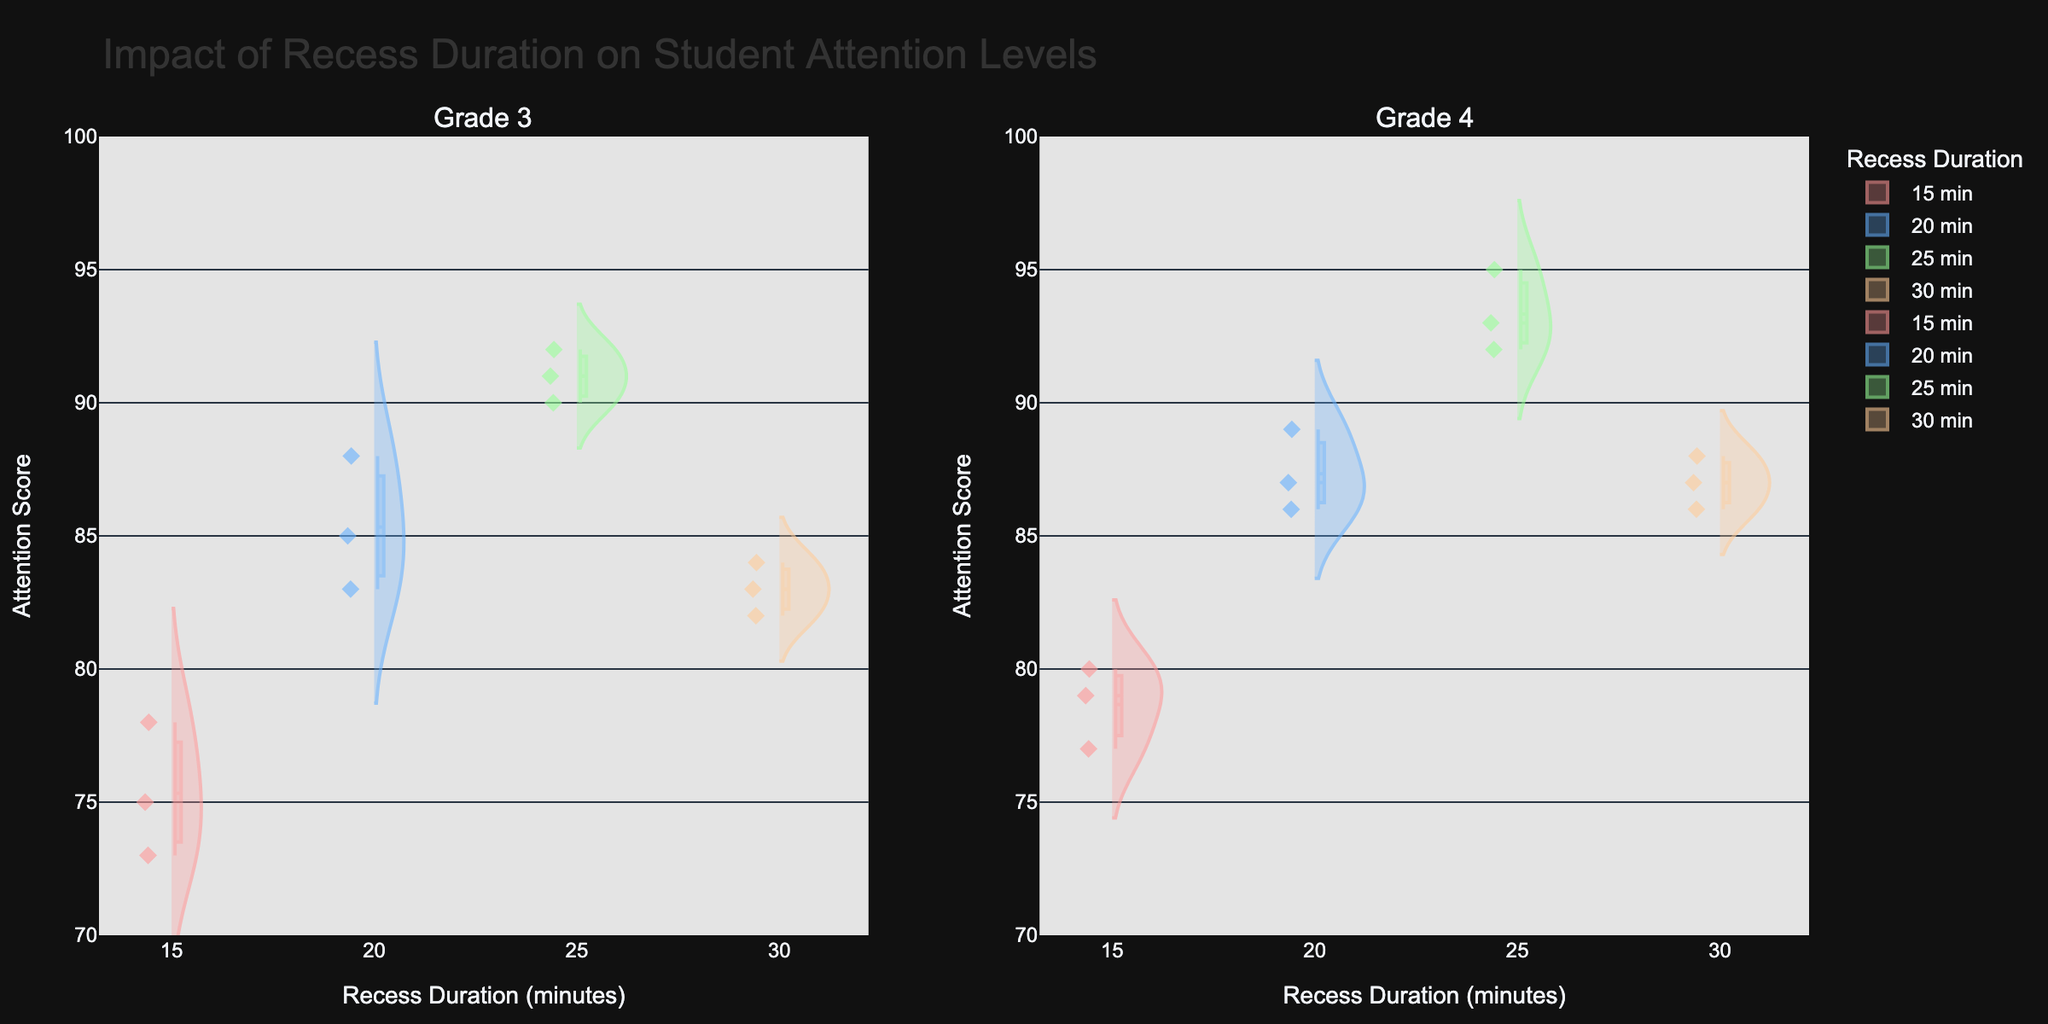What is the title of the figure? Look at the top of the figure to see the main heading. The title should clearly describe the plot's purpose.
Answer: Impact of Recess Duration on Student Attention Levels Which grade levels are compared in this plot? The subplot titles indicate the grade levels being compared.
Answer: Grade 3 and Grade 4 What does the y-axis represent? Examine the label on the y-axis to determine what measurement is being shown.
Answer: Attention Score What is the range of attention scores displayed on the y-axis? Look at the numeric values on the y-axis to determine the minimum and maximum values.
Answer: 70 to 100 Which recess duration has the highest average attention score for grade 4? Look for the mean line within each violin plot for grade 4, which indicates the average attention score for each recess duration.
Answer: 25 minutes What is the difference between the average attention score of 15 minutes and 25 minutes recess for grade 3? Find the mean lines for 15 minutes and 25 minutes recess in the grade 3 plot, then calculate the difference between these mean values.
Answer: 18 Which recess duration displays the most varied attention scores for grade 3? Assess the spread or width of the violin plots for each recess duration in the grade 3 plot; the wider the plot, the more varied the data.
Answer: 15 minutes What is the highest attention score recorded for grade 4 with a 20 minutes recess? Check the maximum value on the violin plot for grade 4 with a 20 minutes recess.
Answer: 89 How does the attention score distribution for a 30 minutes recess compare between grade 3 and grade 4? Compare the shape, spread, and central tendency (mean line) of the two violin plots for the 30 minutes recess in grade 3 and grade 4.
Answer: Grade 4 has higher scores For a 20 minutes recess, are the attention scores more consistent (less varied) in grade 3 or grade 4? Compare the spread of the violin plots for a 20 minutes recess between grade 3 and grade 4; a narrower plot indicates less variability.
Answer: Grade 4 